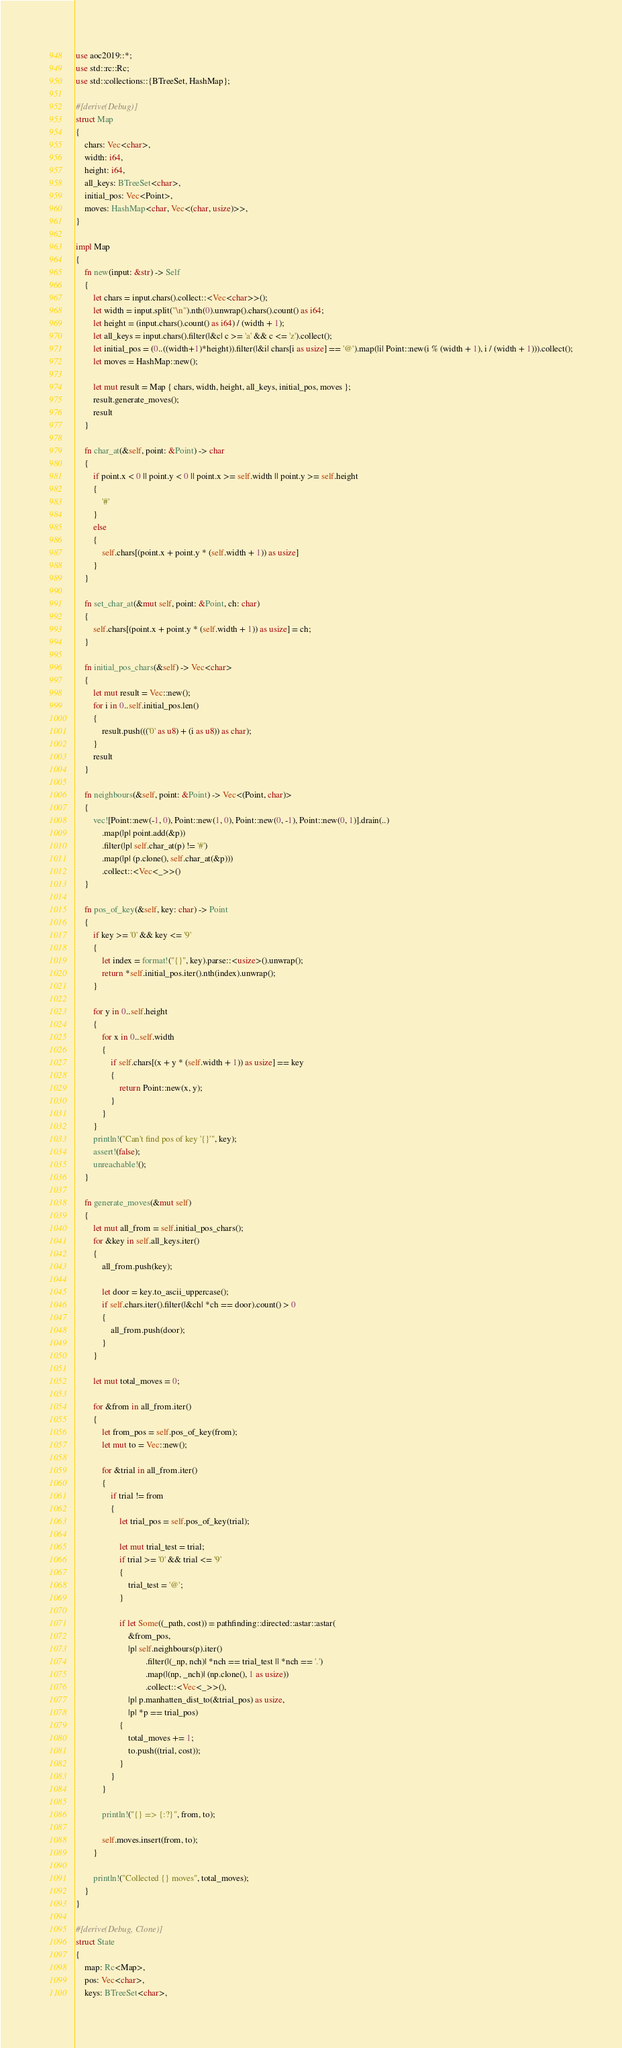<code> <loc_0><loc_0><loc_500><loc_500><_Rust_>use aoc2019::*;
use std::rc::Rc;
use std::collections::{BTreeSet, HashMap};

#[derive(Debug)]
struct Map
{
    chars: Vec<char>,
    width: i64,
    height: i64,
    all_keys: BTreeSet<char>,
    initial_pos: Vec<Point>,
    moves: HashMap<char, Vec<(char, usize)>>,
}

impl Map
{
    fn new(input: &str) -> Self
    {
        let chars = input.chars().collect::<Vec<char>>();
        let width = input.split("\n").nth(0).unwrap().chars().count() as i64;
        let height = (input.chars().count() as i64) / (width + 1);
        let all_keys = input.chars().filter(|&c| c >= 'a' && c <= 'z').collect();
        let initial_pos = (0..((width+1)*height)).filter(|&i| chars[i as usize] == '@').map(|i| Point::new(i % (width + 1), i / (width + 1))).collect();
        let moves = HashMap::new();

        let mut result = Map { chars, width, height, all_keys, initial_pos, moves };
        result.generate_moves();
        result
    }

    fn char_at(&self, point: &Point) -> char
    {
        if point.x < 0 || point.y < 0 || point.x >= self.width || point.y >= self.height
        {
            '#'
        }
        else
        {
            self.chars[(point.x + point.y * (self.width + 1)) as usize]
        }
    }

    fn set_char_at(&mut self, point: &Point, ch: char)
    {
        self.chars[(point.x + point.y * (self.width + 1)) as usize] = ch;
    }

    fn initial_pos_chars(&self) -> Vec<char>
    {
        let mut result = Vec::new();
        for i in 0..self.initial_pos.len()
        {
            result.push((('0' as u8) + (i as u8)) as char);
        }
        result
    }

    fn neighbours(&self, point: &Point) -> Vec<(Point, char)>
    {
        vec![Point::new(-1, 0), Point::new(1, 0), Point::new(0, -1), Point::new(0, 1)].drain(..)
            .map(|p| point.add(&p))
            .filter(|p| self.char_at(p) != '#')
            .map(|p| (p.clone(), self.char_at(&p)))
            .collect::<Vec<_>>()
    }

    fn pos_of_key(&self, key: char) -> Point
    {
        if key >= '0' && key <= '9'
        {
            let index = format!("{}", key).parse::<usize>().unwrap();
            return *self.initial_pos.iter().nth(index).unwrap();
        }

        for y in 0..self.height
        {
            for x in 0..self.width
            {
                if self.chars[(x + y * (self.width + 1)) as usize] == key
                {
                    return Point::new(x, y);
                }
            }
        }
        println!("Can't find pos of key '{}'", key);
        assert!(false);
        unreachable!();
    }

    fn generate_moves(&mut self)
    {
        let mut all_from = self.initial_pos_chars();
        for &key in self.all_keys.iter()
        {
            all_from.push(key);

            let door = key.to_ascii_uppercase();
            if self.chars.iter().filter(|&ch| *ch == door).count() > 0
            {
                all_from.push(door);
            }
        }

        let mut total_moves = 0;

        for &from in all_from.iter()
        {
            let from_pos = self.pos_of_key(from);
            let mut to = Vec::new();

            for &trial in all_from.iter()
            {
                if trial != from
                {
                    let trial_pos = self.pos_of_key(trial);

                    let mut trial_test = trial;
                    if trial >= '0' && trial <= '9'
                    {
                        trial_test = '@';
                    }

                    if let Some((_path, cost)) = pathfinding::directed::astar::astar(
                        &from_pos,
                        |p| self.neighbours(p).iter()
                                .filter(|(_np, nch)| *nch == trial_test || *nch == '.')
                                .map(|(np, _nch)| (np.clone(), 1 as usize))
                                .collect::<Vec<_>>(),
                        |p| p.manhatten_dist_to(&trial_pos) as usize,
                        |p| *p == trial_pos)
                    {
                        total_moves += 1;
                        to.push((trial, cost));
                    }
                }
            }

            println!("{} => {:?}", from, to);

            self.moves.insert(from, to);
        }

        println!("Collected {} moves", total_moves);
    }
}

#[derive(Debug, Clone)]
struct State
{
    map: Rc<Map>,
    pos: Vec<char>,
    keys: BTreeSet<char>,</code> 